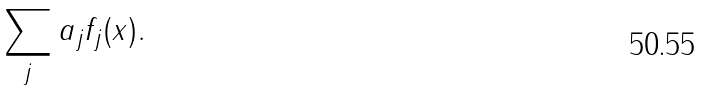Convert formula to latex. <formula><loc_0><loc_0><loc_500><loc_500>\sum _ { j } a _ { j } f _ { j } ( x ) .</formula> 